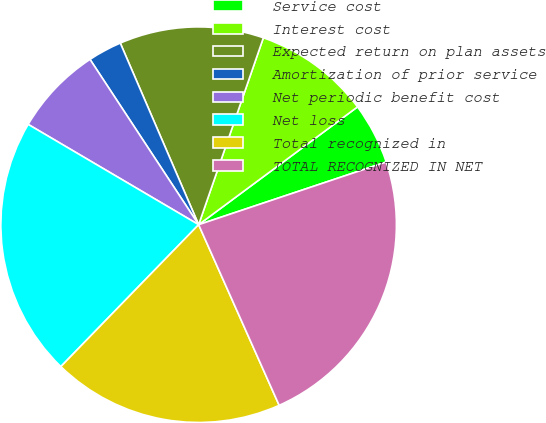Convert chart to OTSL. <chart><loc_0><loc_0><loc_500><loc_500><pie_chart><fcel>Service cost<fcel>Interest cost<fcel>Expected return on plan assets<fcel>Amortization of prior service<fcel>Net periodic benefit cost<fcel>Net loss<fcel>Total recognized in<fcel>TOTAL RECOGNIZED IN NET<nl><fcel>5.02%<fcel>9.54%<fcel>11.79%<fcel>2.77%<fcel>7.28%<fcel>21.2%<fcel>18.94%<fcel>23.46%<nl></chart> 